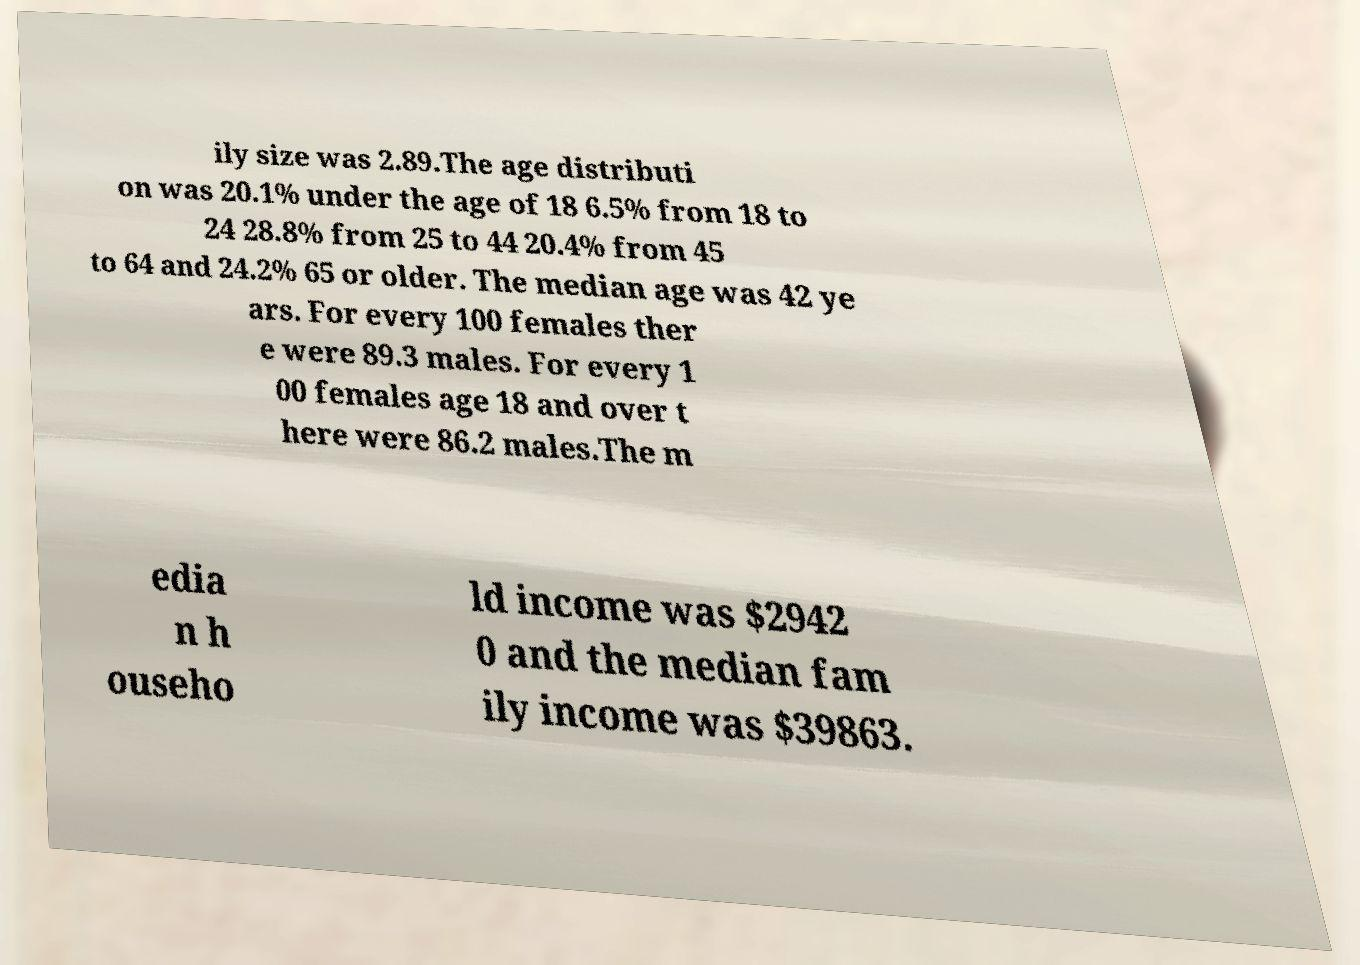Can you accurately transcribe the text from the provided image for me? ily size was 2.89.The age distributi on was 20.1% under the age of 18 6.5% from 18 to 24 28.8% from 25 to 44 20.4% from 45 to 64 and 24.2% 65 or older. The median age was 42 ye ars. For every 100 females ther e were 89.3 males. For every 1 00 females age 18 and over t here were 86.2 males.The m edia n h ouseho ld income was $2942 0 and the median fam ily income was $39863. 